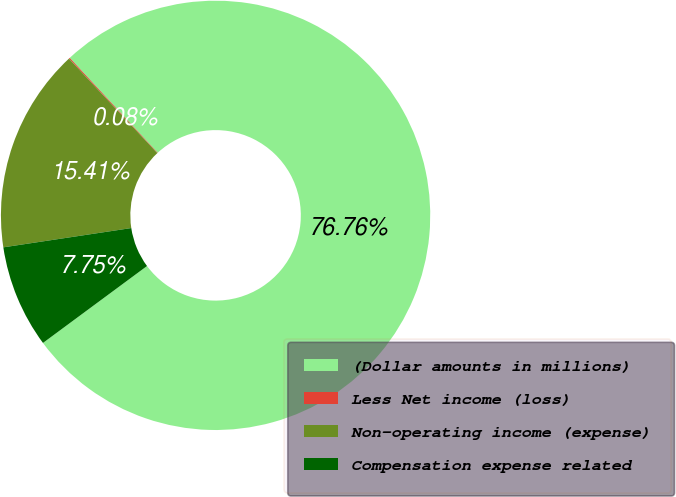<chart> <loc_0><loc_0><loc_500><loc_500><pie_chart><fcel>(Dollar amounts in millions)<fcel>Less Net income (loss)<fcel>Non-operating income (expense)<fcel>Compensation expense related<nl><fcel>76.76%<fcel>0.08%<fcel>15.41%<fcel>7.75%<nl></chart> 